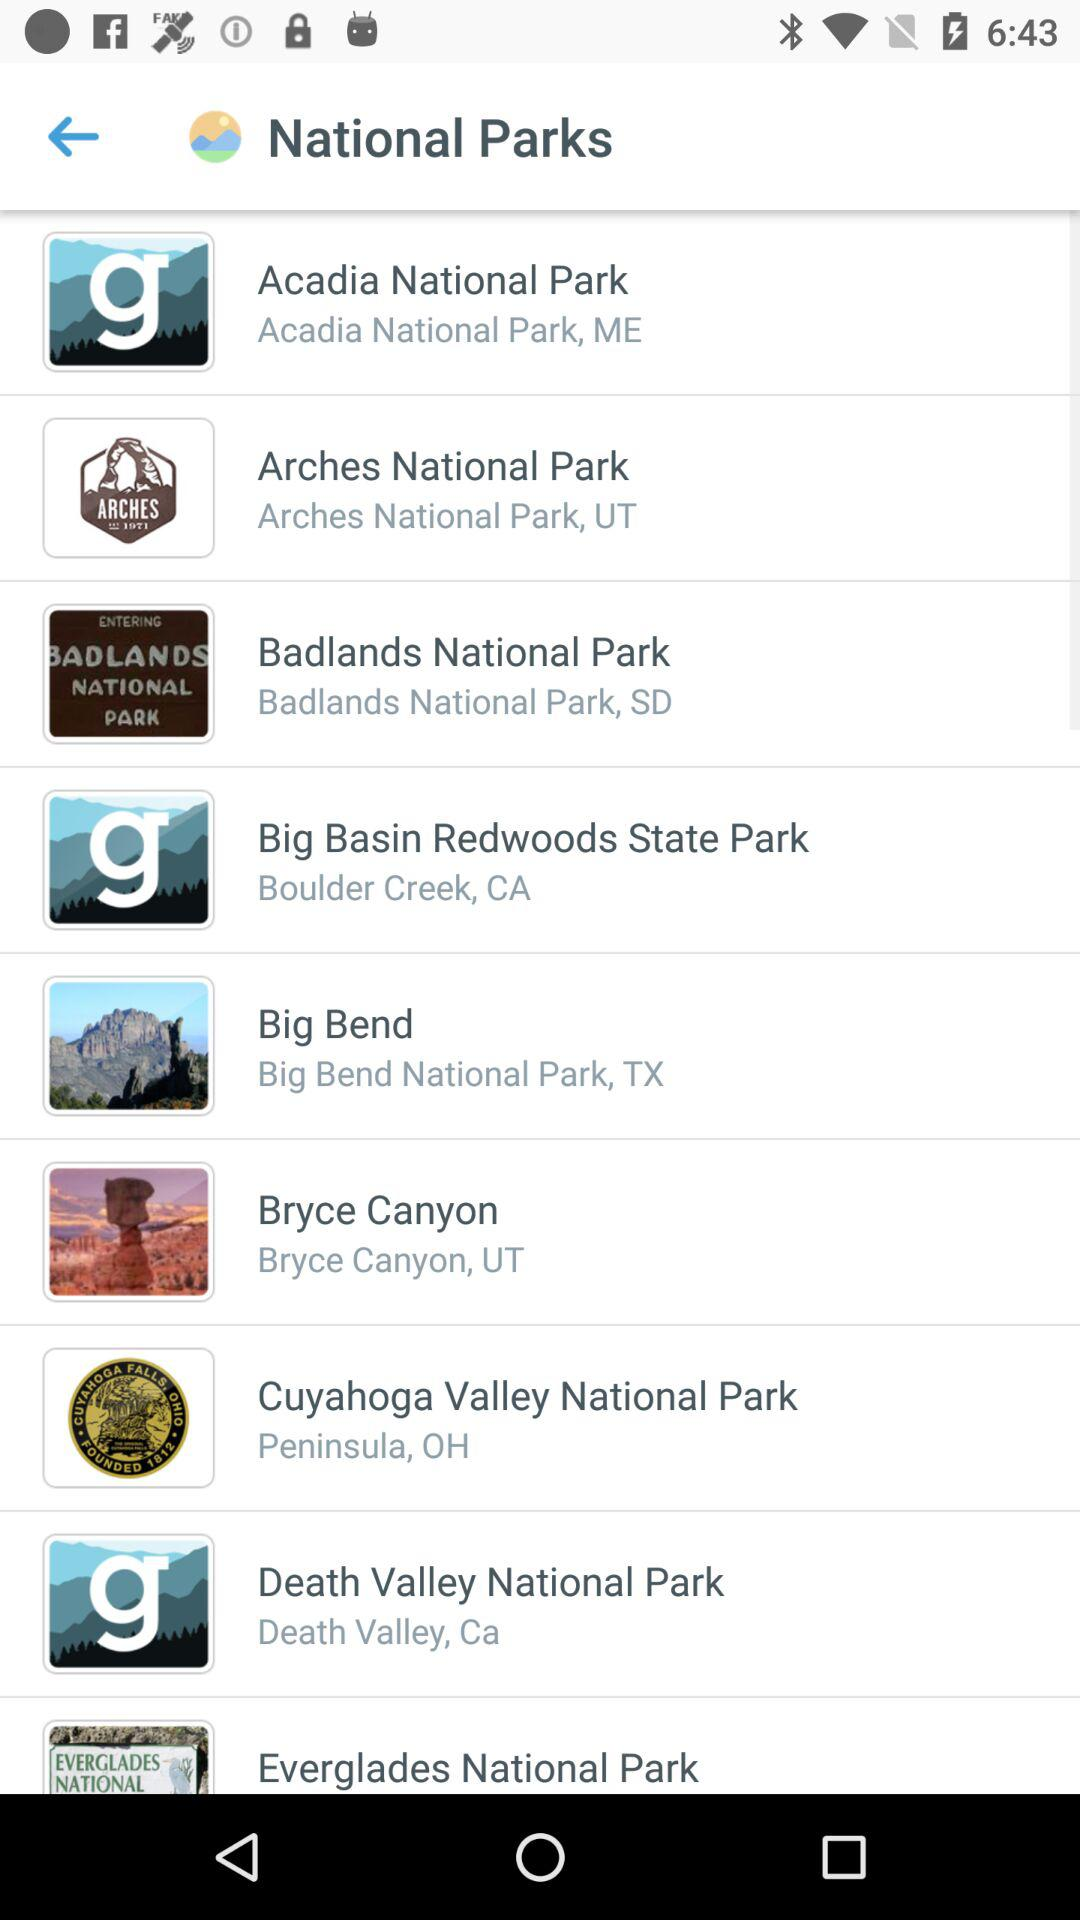Where is Death Valley National Park located? Death Valley National Park is located in Death Valley, California. 